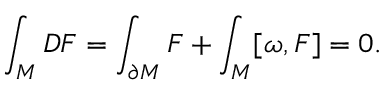<formula> <loc_0><loc_0><loc_500><loc_500>\int _ { M } D F = \int _ { \partial M } F + \int _ { M } [ \omega , F ] = 0 .</formula> 